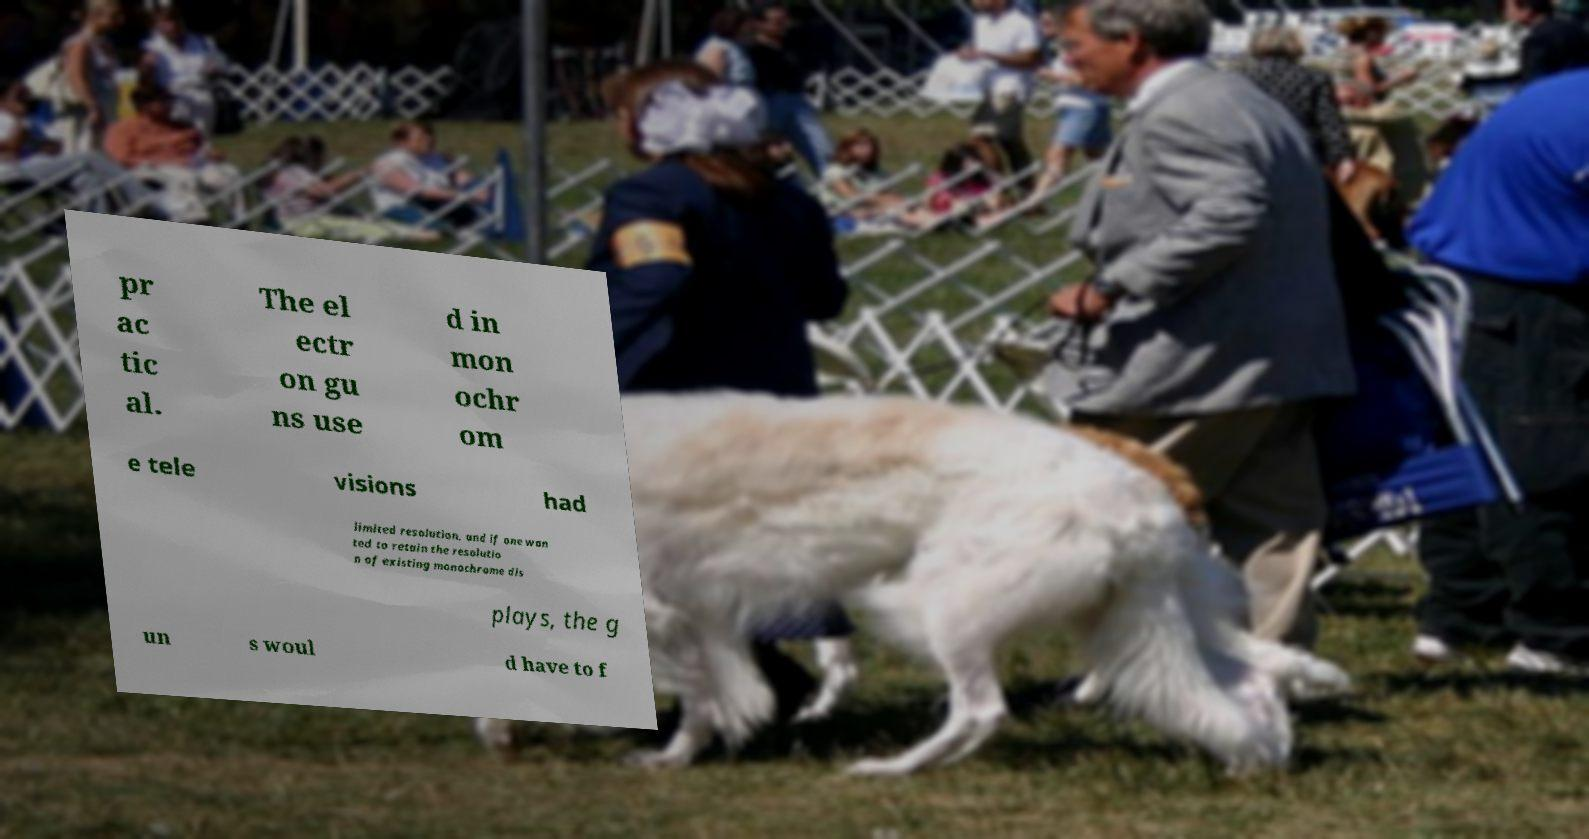Can you accurately transcribe the text from the provided image for me? pr ac tic al. The el ectr on gu ns use d in mon ochr om e tele visions had limited resolution, and if one wan ted to retain the resolutio n of existing monochrome dis plays, the g un s woul d have to f 